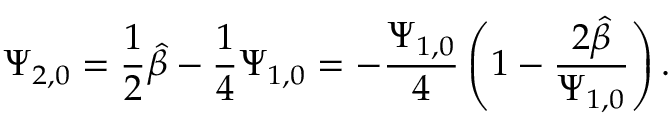<formula> <loc_0><loc_0><loc_500><loc_500>\Psi _ { 2 , 0 } = \frac { 1 } { 2 } \hat { \beta } - \frac { 1 } { 4 } \Psi _ { 1 , 0 } = - \frac { \Psi _ { 1 , 0 } } { 4 } \left ( 1 - \frac { 2 \hat { \beta } } { \Psi _ { 1 , 0 } } \right ) .</formula> 